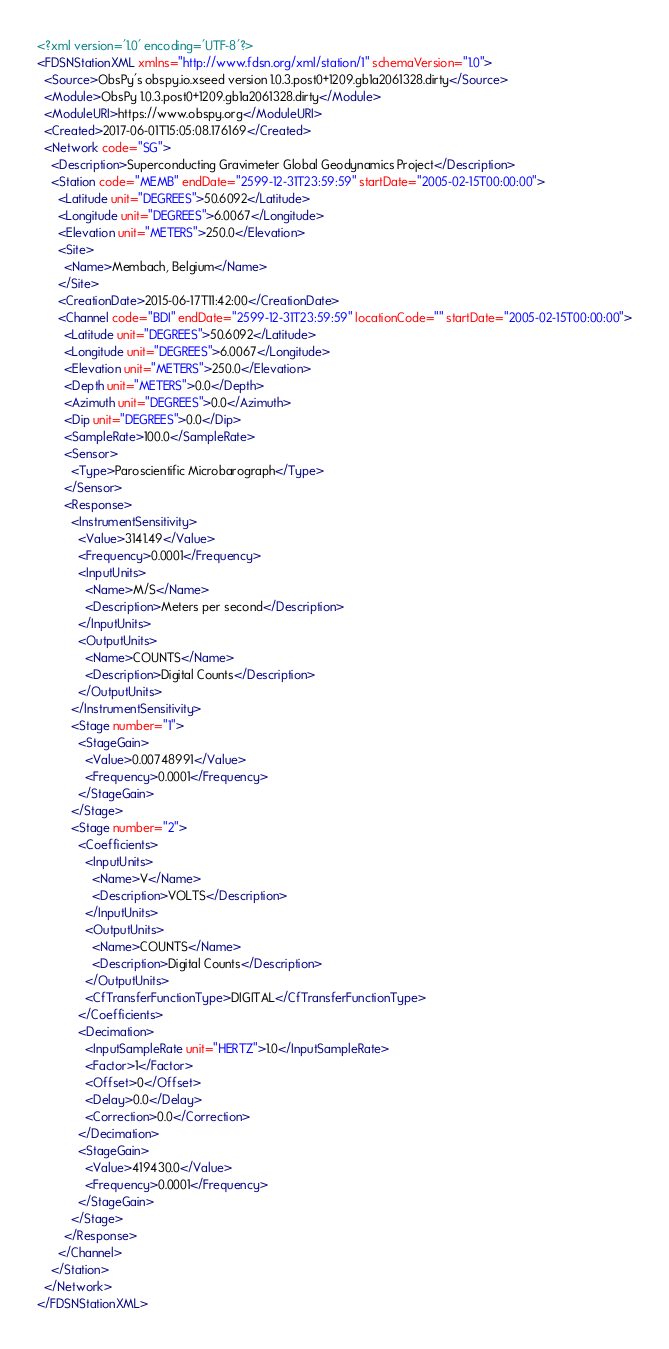Convert code to text. <code><loc_0><loc_0><loc_500><loc_500><_XML_><?xml version='1.0' encoding='UTF-8'?>
<FDSNStationXML xmlns="http://www.fdsn.org/xml/station/1" schemaVersion="1.0">
  <Source>ObsPy's obspy.io.xseed version 1.0.3.post0+1209.gb1a2061328.dirty</Source>
  <Module>ObsPy 1.0.3.post0+1209.gb1a2061328.dirty</Module>
  <ModuleURI>https://www.obspy.org</ModuleURI>
  <Created>2017-06-01T15:05:08.176169</Created>
  <Network code="SG">
    <Description>Superconducting Gravimeter Global Geodynamics Project</Description>
    <Station code="MEMB" endDate="2599-12-31T23:59:59" startDate="2005-02-15T00:00:00">
      <Latitude unit="DEGREES">50.6092</Latitude>
      <Longitude unit="DEGREES">6.0067</Longitude>
      <Elevation unit="METERS">250.0</Elevation>
      <Site>
        <Name>Membach, Belgium</Name>
      </Site>
      <CreationDate>2015-06-17T11:42:00</CreationDate>
      <Channel code="BDI" endDate="2599-12-31T23:59:59" locationCode="" startDate="2005-02-15T00:00:00">
        <Latitude unit="DEGREES">50.6092</Latitude>
        <Longitude unit="DEGREES">6.0067</Longitude>
        <Elevation unit="METERS">250.0</Elevation>
        <Depth unit="METERS">0.0</Depth>
        <Azimuth unit="DEGREES">0.0</Azimuth>
        <Dip unit="DEGREES">0.0</Dip>
        <SampleRate>100.0</SampleRate>
        <Sensor>
          <Type>Paroscientific Microbarograph</Type>
        </Sensor>
        <Response>
          <InstrumentSensitivity>
            <Value>3141.49</Value>
            <Frequency>0.0001</Frequency>
            <InputUnits>
              <Name>M/S</Name>
              <Description>Meters per second</Description>
            </InputUnits>
            <OutputUnits>
              <Name>COUNTS</Name>
              <Description>Digital Counts</Description>
            </OutputUnits>
          </InstrumentSensitivity>
          <Stage number="1">
            <StageGain>
              <Value>0.00748991</Value>
              <Frequency>0.0001</Frequency>
            </StageGain>
          </Stage>
          <Stage number="2">
            <Coefficients>
              <InputUnits>
                <Name>V</Name>
                <Description>VOLTS</Description>
              </InputUnits>
              <OutputUnits>
                <Name>COUNTS</Name>
                <Description>Digital Counts</Description>
              </OutputUnits>
              <CfTransferFunctionType>DIGITAL</CfTransferFunctionType>
            </Coefficients>
            <Decimation>
              <InputSampleRate unit="HERTZ">1.0</InputSampleRate>
              <Factor>1</Factor>
              <Offset>0</Offset>
              <Delay>0.0</Delay>
              <Correction>0.0</Correction>
            </Decimation>
            <StageGain>
              <Value>419430.0</Value>
              <Frequency>0.0001</Frequency>
            </StageGain>
          </Stage>
        </Response>
      </Channel>
    </Station>
  </Network>
</FDSNStationXML>
</code> 